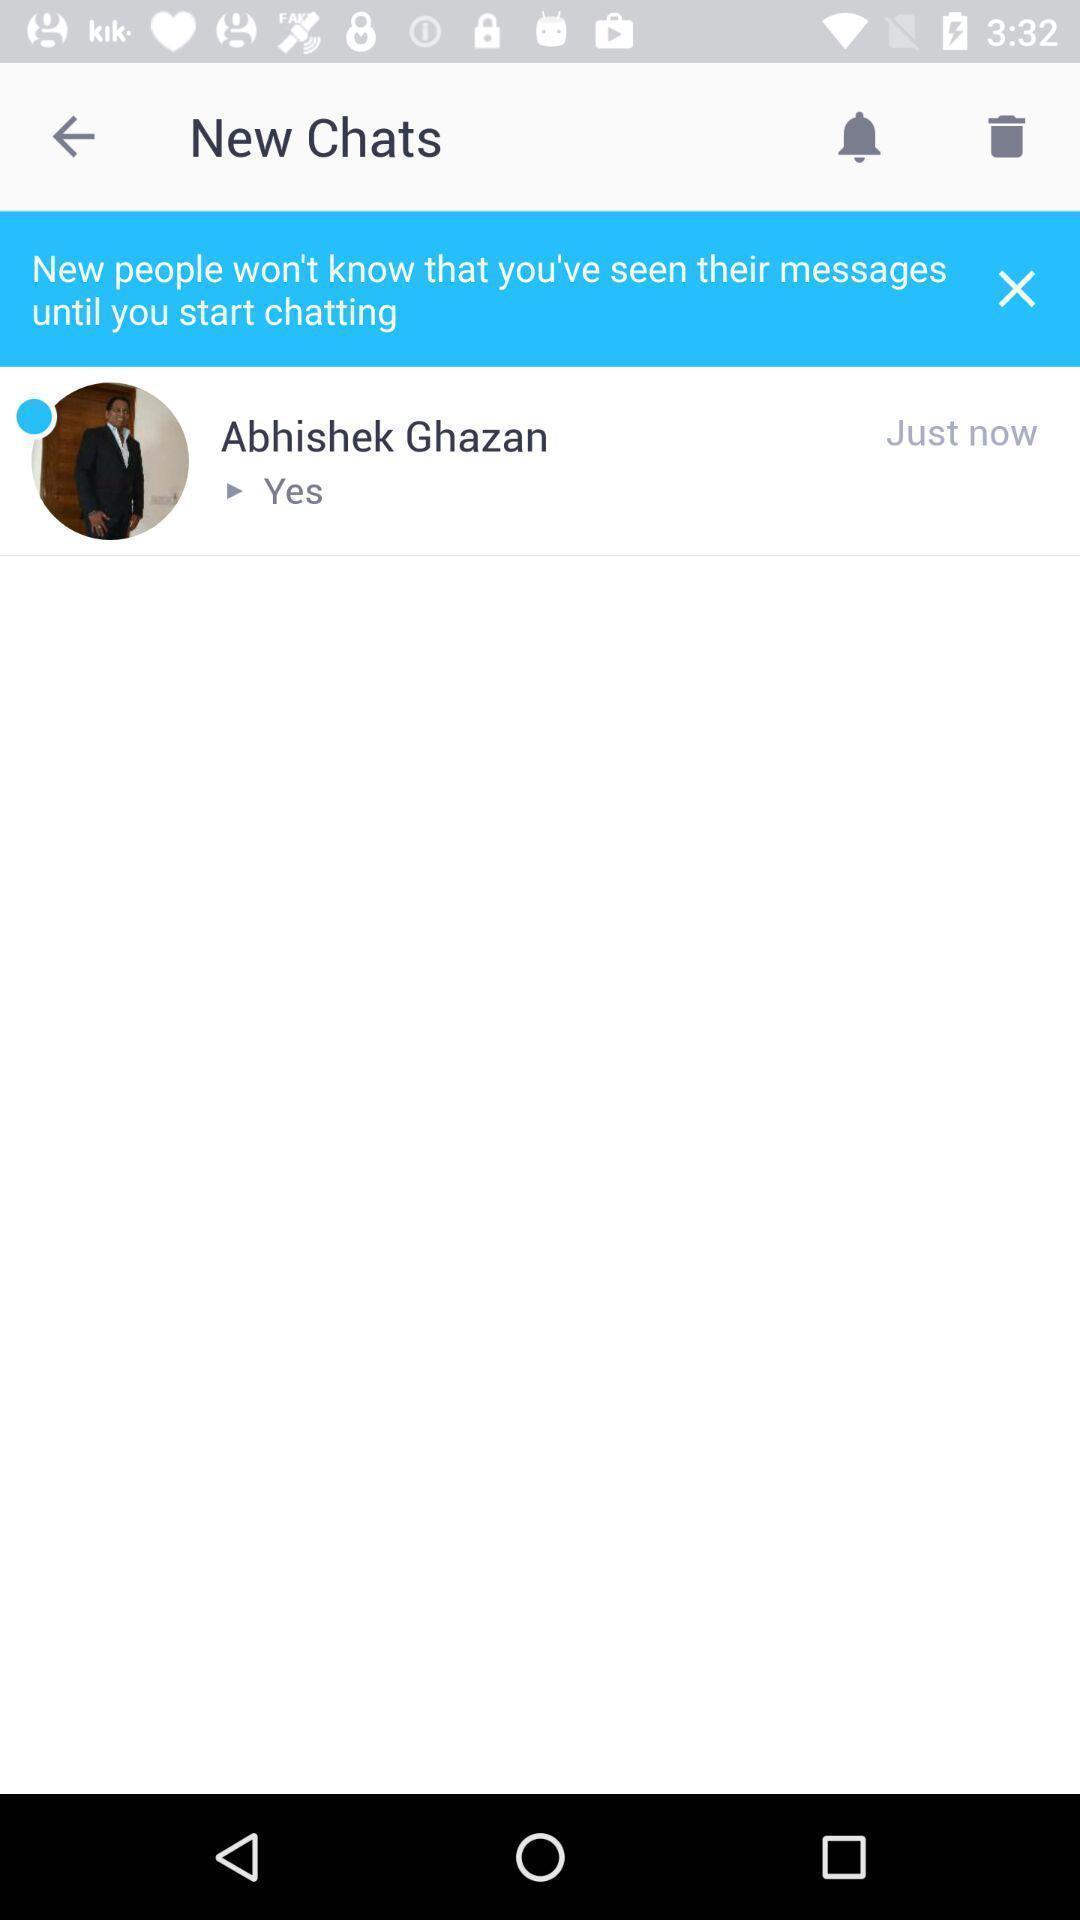Tell me what you see in this picture. Page displaying the chat conversation. 